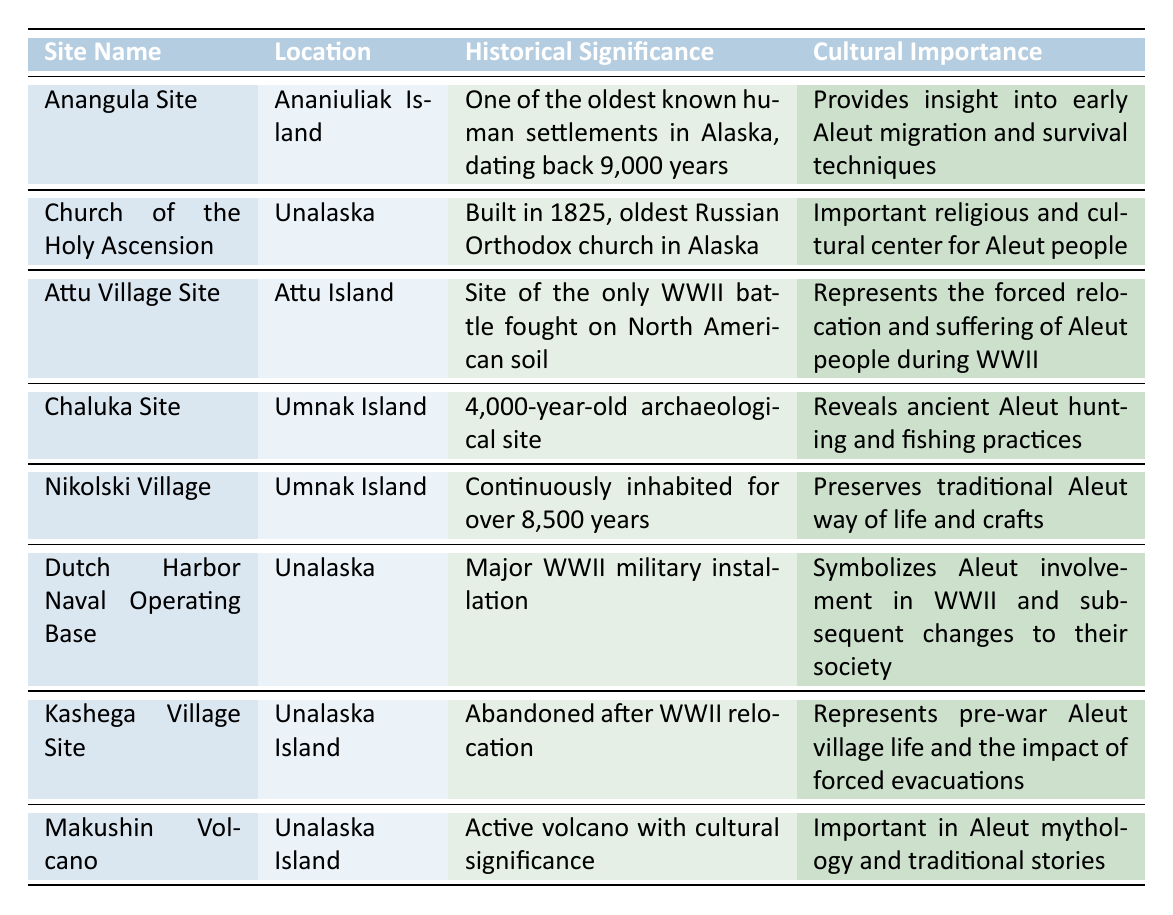What is the historical significance of the Church of the Holy Ascension? The Church of the Holy Ascension is built in 1825 and is the oldest Russian Orthodox church in Alaska. This indicates its importance during the Russian period in the region's history.
Answer: It is the oldest Russian Orthodox church in Alaska Which site is recognized as a major WWII military installation? The table specifies that Dutch Harbor Naval Operating Base located in Unalaska was a major WWII military installation, as per its historical significance.
Answer: Dutch Harbor Naval Operating Base How many years has Nikolski Village been continuously inhabited? The table mentions that Nikolski Village has been continuously inhabited for over 8,500 years, which provides a clear numeric answer.
Answer: Over 8,500 years True or False: The Attu Village Site reflects the cultural importance of Aleut hunting and fishing practices. The Attu Village Site is linked to WWII history rather than hunting and fishing practices, as indicated in the table. Therefore, it does not reflect cultural importance in that context.
Answer: False Which site provides insight into early Aleut migration and survival techniques? According to the table, the Anangula Site, located on Ananiuliak Island, is significant for shedding light on early Aleut migration and survival techniques.
Answer: Anangula Site What is the cultural importance of Makushin Volcano? Makushin Volcano has significant cultural importance in Aleut mythology and traditional stories, according to the table. This identifies its role in spiritual and cultural practices.
Answer: Important in Aleut mythology List the sites located on Unalaska Island. From the table, the sites located on Unalaska Island are the Church of the Holy Ascension, Dutch Harbor Naval Operating Base, Kashega Village Site, and Makushin Volcano. This information can be extracted by filtering the data by location.
Answer: Church of the Holy Ascension, Dutch Harbor Naval Operating Base, Kashega Village Site, Makushin Volcano Which site represents both historical significance related to WWII and the impact of forced evacuations? The table indicates that the Kashega Village Site is linked to both the forced evacuations and represents life before WWII, making it significant in both contexts.
Answer: Kashega Village Site How many archaeological sites are mentioned in the table? The table lists 3 archaeological sites: Anangula Site, Chaluka Site, and Attu Village Site, making it a straightforward count of specific site types.
Answer: 3 archaeological sites 